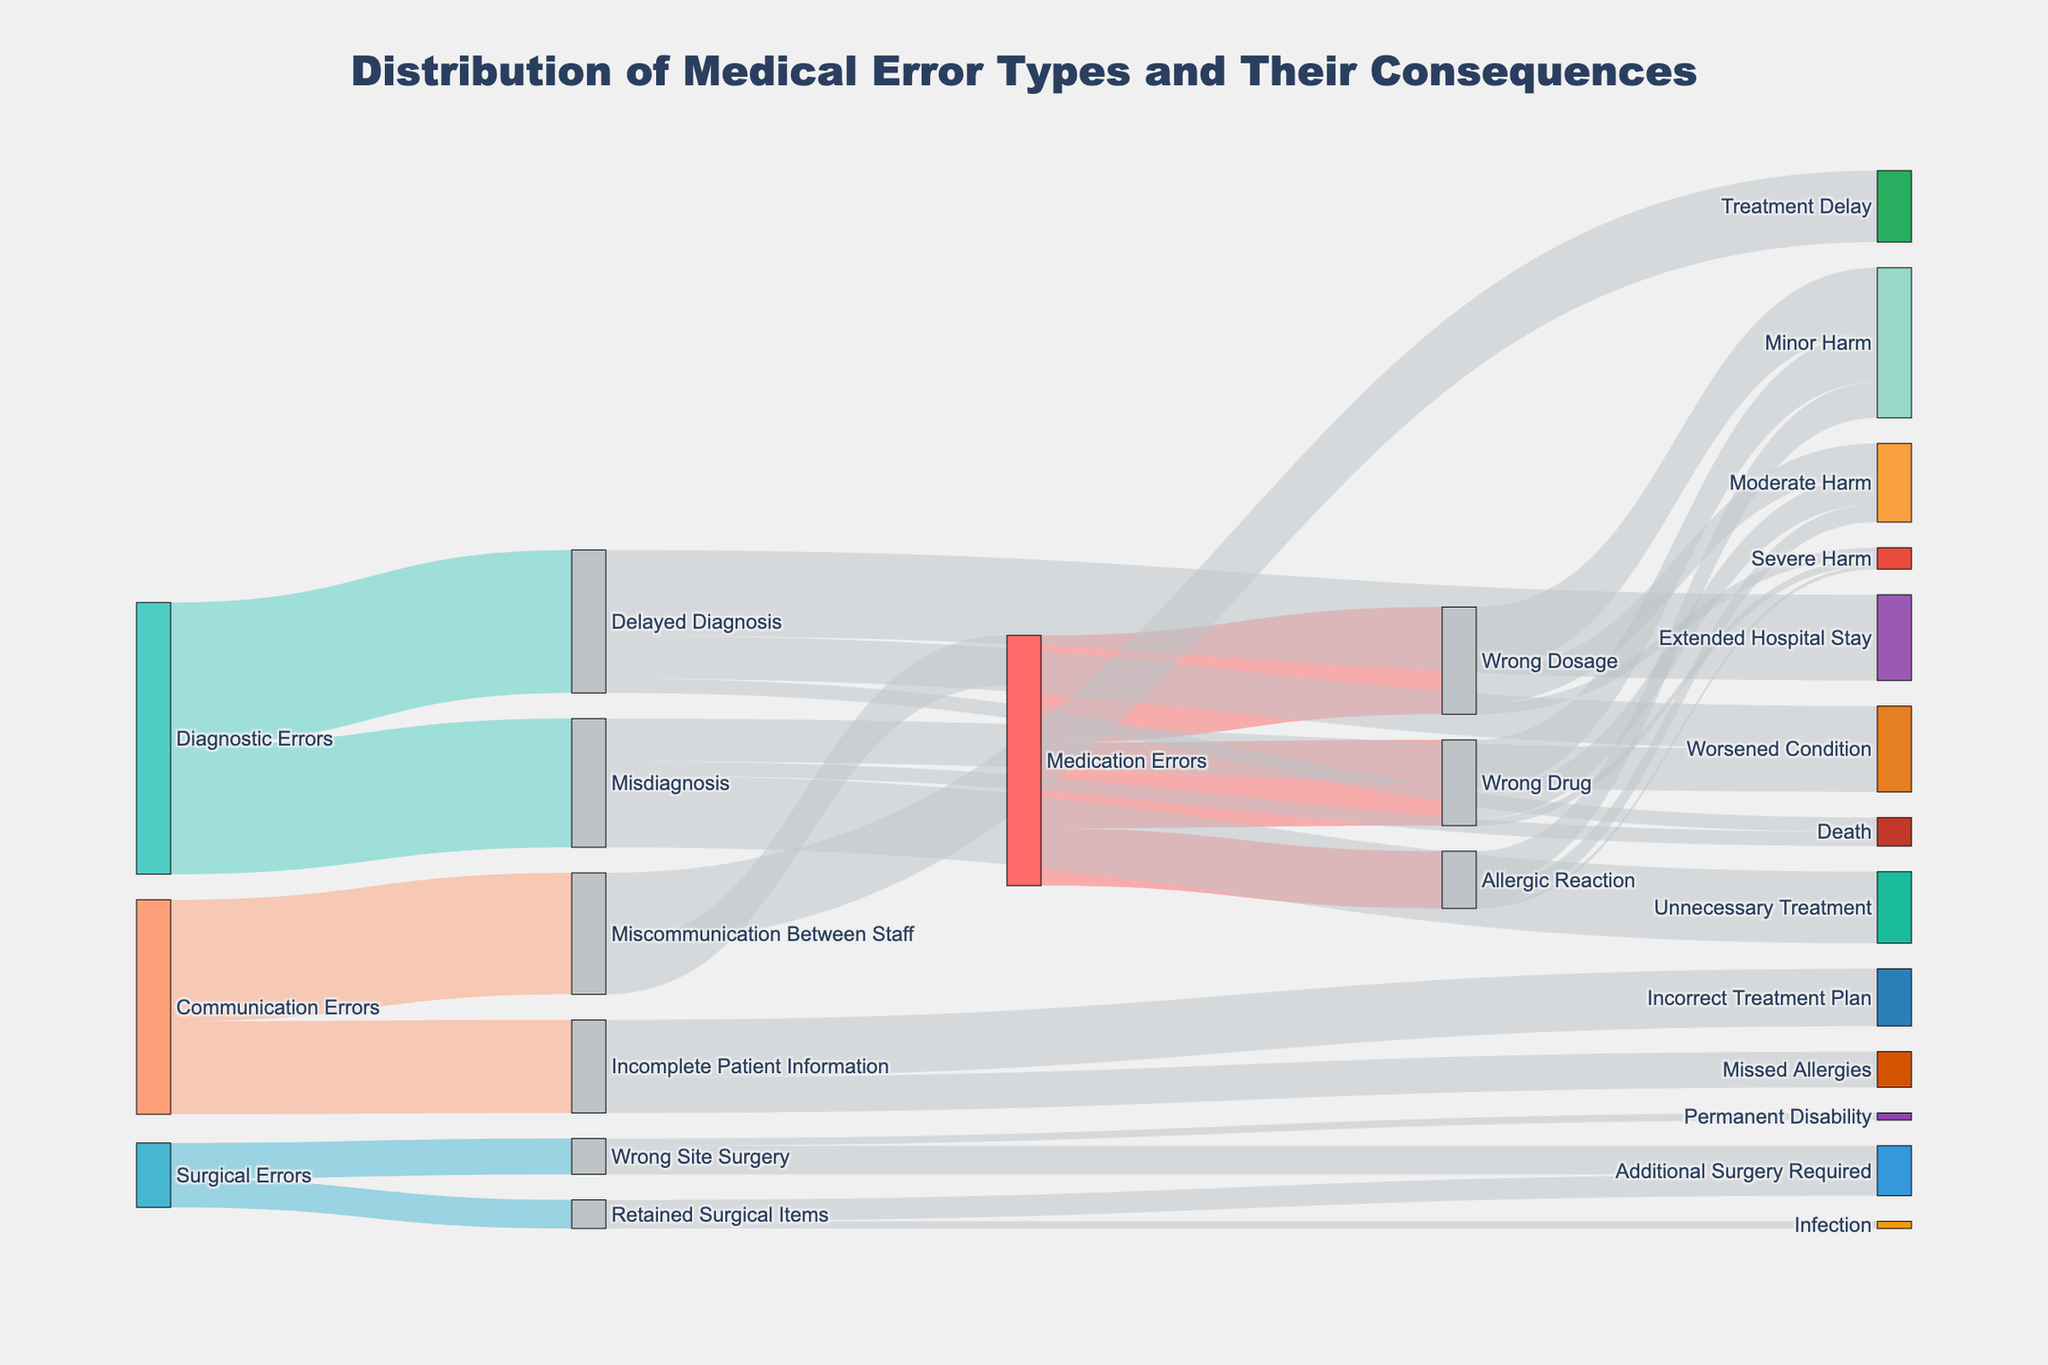What's the most common type of medical error causing minor harm? Medication Errors has the categories Wrong Dosage, Wrong Drug, and Allergic Reaction which have 900, 700, and 500 instances of minor harm respectively. Adding up related categories, the highest is Wrong Dosage causing 900 instances, which is the highest among all medical error types causing minor harm.
Answer: Wrong Dosage How many cases of communication errors resulted in incorrect treatment plans? By tracing the Communication Errors node to its subsequent branches, Incomplete Patient Information results in Incorrect Treatment Plans with 800 cases.
Answer: 800 What is the total number of misdiagnosis cases leading to death? The Diagnostic Errors category includes Misdiagnosis which branches into Death with 200 cases.
Answer: 200 Which medical error type causes the least severe harm? Comparing the severe harm nodes for each medical error type, Allergic Reaction has the lowest value of 50 cases.
Answer: Allergic Reaction How many surgical errors led to additional surgeries? Addition of cases from Wrong Site Surgery (400) and Retained Surgical Items (300) leading to additional surgeries gives a total of 700 cases.
Answer: 700 What is the consequence with the highest occurrence from diagnostic errors? Diagnostic Errors branch into Delayed Diagnosis and Misdiagnosis. Comparing their highest subsequent branches, Delayed Diagnosis leads to Extended Hospital Stay with 1200 cases, which is the highest occurrence.
Answer: Extended Hospital Stay Which type of from communication errors is more common—treatment delays or medication errors? Miscommunication Between Staff leads to Treatment Delay (1000) and Medication Errors (700). Treatment Delay is more common with 1000 cases.
Answer: Treatment Delay What's the sum of moderate harms caused by medication errors? Adding moderate harm values from Wrong Dosage (450), Wrong Drug (400), and Allergic Reaction (250) gives a total of 1100 cases.
Answer: 1100 Which category among medical errors, diagnostic errors, surgical errors, or communication errors results in the most instances of death, and how many? From Medications Errors, Diagnostic Errors, Surgical Errors, and Communications Errors, only Diagnostic Errors (Delayed Diagnosis and Misdiagnosis) lead to death with total cases of 200 + 200 = 400.
Answer: Diagnostic Errors with 400 instances 